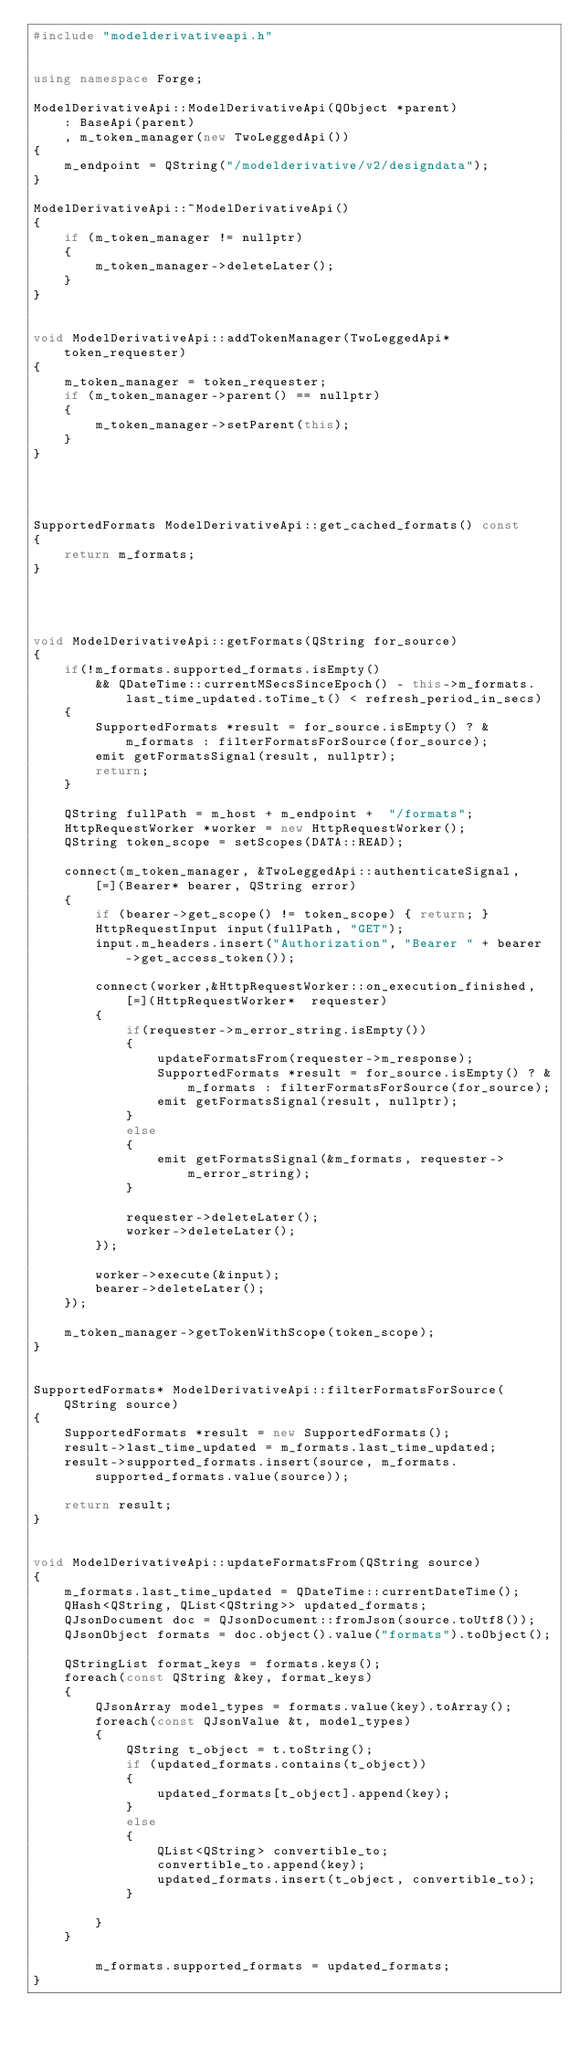<code> <loc_0><loc_0><loc_500><loc_500><_C++_>#include "modelderivativeapi.h"


using namespace Forge;

ModelDerivativeApi::ModelDerivativeApi(QObject *parent)
	: BaseApi(parent)
	, m_token_manager(new TwoLeggedApi())
{
	m_endpoint = QString("/modelderivative/v2/designdata");
}

ModelDerivativeApi::~ModelDerivativeApi()
{
	if (m_token_manager != nullptr)
	{
		m_token_manager->deleteLater();
	}
}


void ModelDerivativeApi::addTokenManager(TwoLeggedApi* token_requester)
{
	m_token_manager = token_requester;
	if (m_token_manager->parent() == nullptr)
	{
		m_token_manager->setParent(this);
	}
}




SupportedFormats ModelDerivativeApi::get_cached_formats() const
{
	return m_formats;
}




void ModelDerivativeApi::getFormats(QString for_source)
{
	if(!m_formats.supported_formats.isEmpty() 
        && QDateTime::currentMSecsSinceEpoch() - this->m_formats.last_time_updated.toTime_t() < refresh_period_in_secs)
	{
		SupportedFormats *result = for_source.isEmpty() ? &m_formats : filterFormatsForSource(for_source);
		emit getFormatsSignal(result, nullptr);
		return;
	}

	QString fullPath = m_host + m_endpoint +  "/formats";
	HttpRequestWorker *worker = new HttpRequestWorker();
	QString token_scope = setScopes(DATA::READ);

	connect(m_token_manager, &TwoLeggedApi::authenticateSignal, [=](Bearer* bearer, QString error)
	{
		if (bearer->get_scope() != token_scope) { return; }
		HttpRequestInput input(fullPath, "GET");
		input.m_headers.insert("Authorization", "Bearer " + bearer->get_access_token());

		connect(worker,&HttpRequestWorker::on_execution_finished, [=](HttpRequestWorker*  requester)
		{
			if(requester->m_error_string.isEmpty())
			{
				updateFormatsFrom(requester->m_response);
				SupportedFormats *result = for_source.isEmpty() ? &m_formats : filterFormatsForSource(for_source);
				emit getFormatsSignal(result, nullptr);
			}
			else
			{
				emit getFormatsSignal(&m_formats, requester->m_error_string);
			}

			requester->deleteLater();
			worker->deleteLater();
		});

		worker->execute(&input);
		bearer->deleteLater();
	});

	m_token_manager->getTokenWithScope(token_scope);
}


SupportedFormats* ModelDerivativeApi::filterFormatsForSource(QString source)
{
	SupportedFormats *result = new SupportedFormats();
	result->last_time_updated = m_formats.last_time_updated;
	result->supported_formats.insert(source, m_formats.supported_formats.value(source));

	return result;
}


void ModelDerivativeApi::updateFormatsFrom(QString source)
{
	m_formats.last_time_updated = QDateTime::currentDateTime();
	QHash<QString, QList<QString>> updated_formats;
	QJsonDocument doc = QJsonDocument::fromJson(source.toUtf8());
    QJsonObject formats = doc.object().value("formats").toObject();

    QStringList format_keys = formats.keys();
    foreach(const QString &key, format_keys)
    {
        QJsonArray model_types = formats.value(key).toArray();
        foreach(const QJsonValue &t, model_types)
        {
            QString t_object = t.toString();
            if (updated_formats.contains(t_object))
            {
                updated_formats[t_object].append(key);
            }
            else
            {
                QList<QString> convertible_to;
                convertible_to.append(key);
                updated_formats.insert(t_object, convertible_to);
            }

        }
    }

		m_formats.supported_formats = updated_formats;
}
</code> 